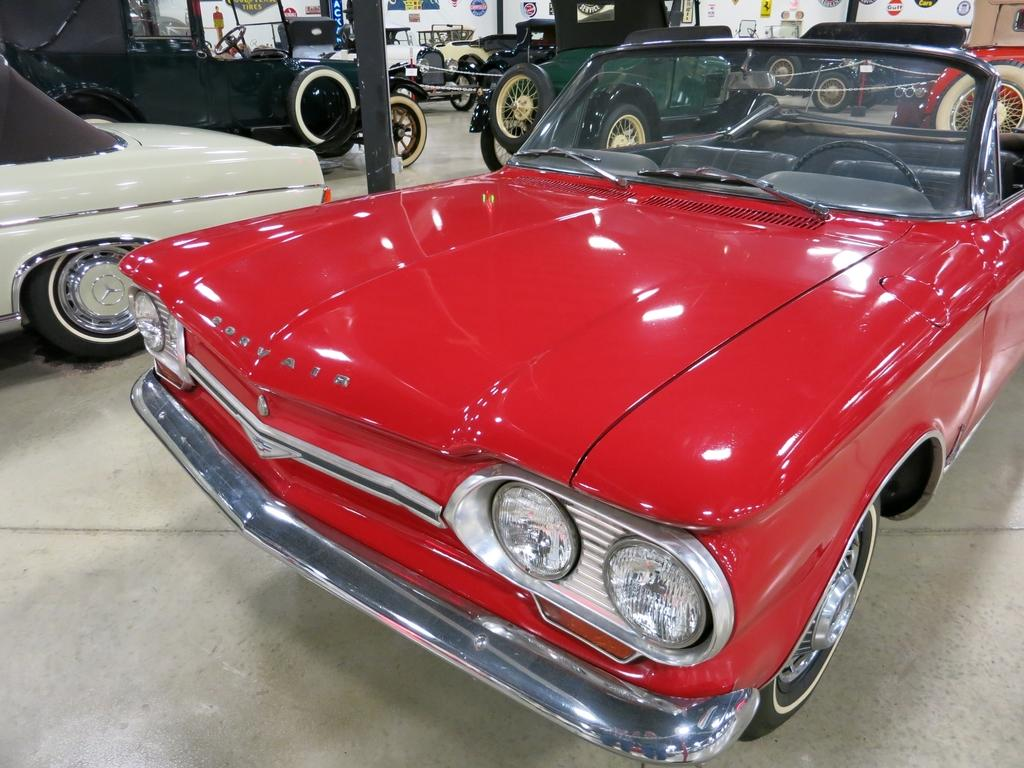What type of vehicles are in the image? There are vintage cars in the image. Can you describe the colors of the vintage cars? The vintage cars are of different colors. What is the surface on which the vintage cars are placed? There is a floor visible in the image. What can be seen in the background of the image? There is a white wall in the background of the image. What is on the white wall? The white wall has many stickers on it. How does the selection of root vegetables contribute to the vintage car's performance in the image? There is no mention of root vegetables in the image, so their contribution to the vintage car's performance cannot be determined. 